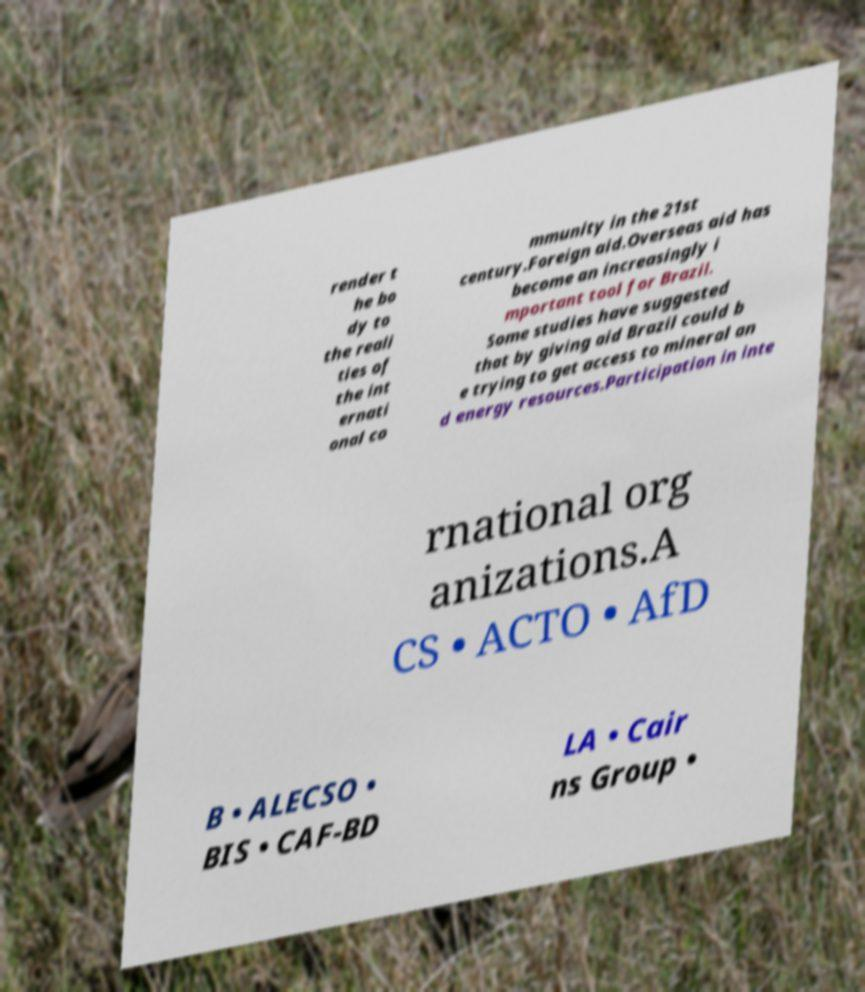I need the written content from this picture converted into text. Can you do that? render t he bo dy to the reali ties of the int ernati onal co mmunity in the 21st century.Foreign aid.Overseas aid has become an increasingly i mportant tool for Brazil. Some studies have suggested that by giving aid Brazil could b e trying to get access to mineral an d energy resources.Participation in inte rnational org anizations.A CS • ACTO • AfD B • ALECSO • BIS • CAF-BD LA • Cair ns Group • 